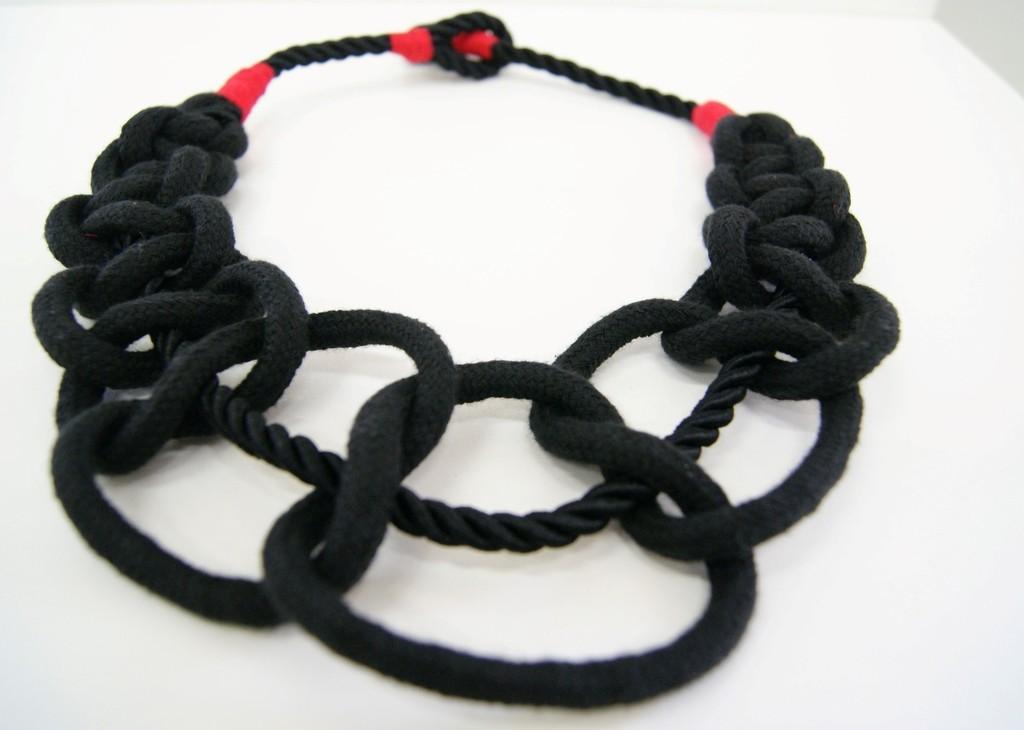Describe this image in one or two sentences. In this picture I can see there is a black color ropes and it has some red color decoration and it is placed on the white surface. 